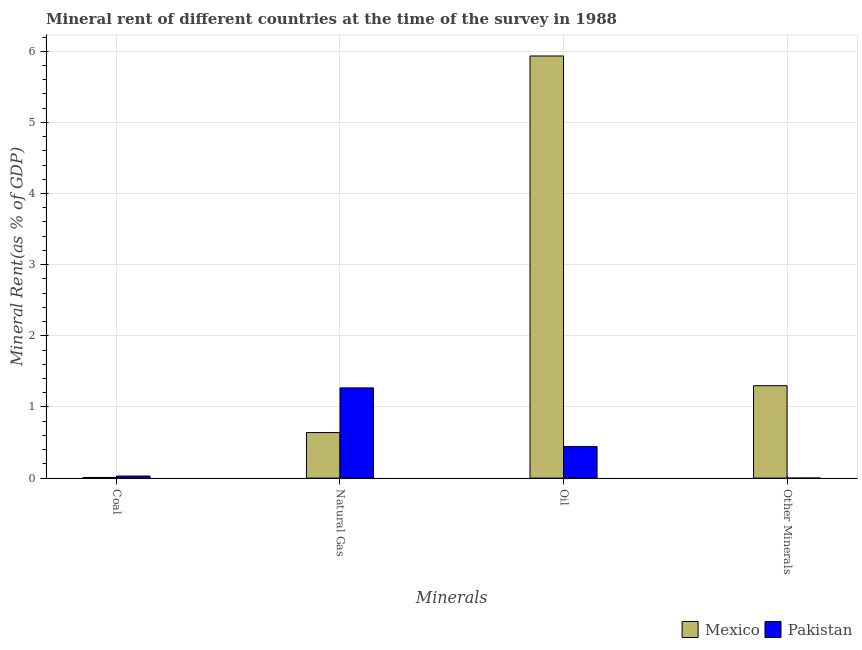What is the label of the 4th group of bars from the left?
Offer a very short reply. Other Minerals. What is the  rent of other minerals in Pakistan?
Offer a terse response. 0. Across all countries, what is the maximum natural gas rent?
Ensure brevity in your answer.  1.27. Across all countries, what is the minimum coal rent?
Your answer should be very brief. 0.01. In which country was the oil rent maximum?
Ensure brevity in your answer.  Mexico. In which country was the natural gas rent minimum?
Provide a short and direct response. Mexico. What is the total coal rent in the graph?
Keep it short and to the point. 0.04. What is the difference between the coal rent in Mexico and that in Pakistan?
Make the answer very short. -0.02. What is the difference between the  rent of other minerals in Pakistan and the natural gas rent in Mexico?
Offer a very short reply. -0.64. What is the average oil rent per country?
Keep it short and to the point. 3.19. What is the difference between the coal rent and oil rent in Pakistan?
Give a very brief answer. -0.41. In how many countries, is the oil rent greater than 2.8 %?
Keep it short and to the point. 1. What is the ratio of the oil rent in Mexico to that in Pakistan?
Give a very brief answer. 13.37. What is the difference between the highest and the second highest coal rent?
Offer a terse response. 0.02. What is the difference between the highest and the lowest natural gas rent?
Ensure brevity in your answer.  0.63. Is it the case that in every country, the sum of the coal rent and natural gas rent is greater than the oil rent?
Provide a succinct answer. No. How many bars are there?
Make the answer very short. 8. Are the values on the major ticks of Y-axis written in scientific E-notation?
Offer a terse response. No. Does the graph contain grids?
Offer a very short reply. Yes. What is the title of the graph?
Provide a succinct answer. Mineral rent of different countries at the time of the survey in 1988. Does "Monaco" appear as one of the legend labels in the graph?
Your response must be concise. No. What is the label or title of the X-axis?
Offer a very short reply. Minerals. What is the label or title of the Y-axis?
Make the answer very short. Mineral Rent(as % of GDP). What is the Mineral Rent(as % of GDP) in Mexico in Coal?
Ensure brevity in your answer.  0.01. What is the Mineral Rent(as % of GDP) of Pakistan in Coal?
Provide a short and direct response. 0.03. What is the Mineral Rent(as % of GDP) in Mexico in Natural Gas?
Give a very brief answer. 0.64. What is the Mineral Rent(as % of GDP) in Pakistan in Natural Gas?
Your response must be concise. 1.27. What is the Mineral Rent(as % of GDP) in Mexico in Oil?
Provide a succinct answer. 5.93. What is the Mineral Rent(as % of GDP) in Pakistan in Oil?
Make the answer very short. 0.44. What is the Mineral Rent(as % of GDP) in Mexico in Other Minerals?
Ensure brevity in your answer.  1.3. What is the Mineral Rent(as % of GDP) in Pakistan in Other Minerals?
Provide a succinct answer. 0. Across all Minerals, what is the maximum Mineral Rent(as % of GDP) of Mexico?
Ensure brevity in your answer.  5.93. Across all Minerals, what is the maximum Mineral Rent(as % of GDP) of Pakistan?
Offer a very short reply. 1.27. Across all Minerals, what is the minimum Mineral Rent(as % of GDP) of Mexico?
Your response must be concise. 0.01. Across all Minerals, what is the minimum Mineral Rent(as % of GDP) in Pakistan?
Your answer should be very brief. 0. What is the total Mineral Rent(as % of GDP) of Mexico in the graph?
Make the answer very short. 7.88. What is the total Mineral Rent(as % of GDP) of Pakistan in the graph?
Offer a very short reply. 1.74. What is the difference between the Mineral Rent(as % of GDP) of Mexico in Coal and that in Natural Gas?
Give a very brief answer. -0.63. What is the difference between the Mineral Rent(as % of GDP) in Pakistan in Coal and that in Natural Gas?
Keep it short and to the point. -1.24. What is the difference between the Mineral Rent(as % of GDP) of Mexico in Coal and that in Oil?
Your answer should be compact. -5.92. What is the difference between the Mineral Rent(as % of GDP) in Pakistan in Coal and that in Oil?
Give a very brief answer. -0.41. What is the difference between the Mineral Rent(as % of GDP) in Mexico in Coal and that in Other Minerals?
Provide a short and direct response. -1.29. What is the difference between the Mineral Rent(as % of GDP) in Pakistan in Coal and that in Other Minerals?
Provide a succinct answer. 0.03. What is the difference between the Mineral Rent(as % of GDP) of Mexico in Natural Gas and that in Oil?
Ensure brevity in your answer.  -5.29. What is the difference between the Mineral Rent(as % of GDP) in Pakistan in Natural Gas and that in Oil?
Ensure brevity in your answer.  0.82. What is the difference between the Mineral Rent(as % of GDP) of Mexico in Natural Gas and that in Other Minerals?
Offer a very short reply. -0.66. What is the difference between the Mineral Rent(as % of GDP) of Pakistan in Natural Gas and that in Other Minerals?
Your answer should be compact. 1.27. What is the difference between the Mineral Rent(as % of GDP) of Mexico in Oil and that in Other Minerals?
Ensure brevity in your answer.  4.63. What is the difference between the Mineral Rent(as % of GDP) of Pakistan in Oil and that in Other Minerals?
Your answer should be very brief. 0.44. What is the difference between the Mineral Rent(as % of GDP) in Mexico in Coal and the Mineral Rent(as % of GDP) in Pakistan in Natural Gas?
Offer a terse response. -1.26. What is the difference between the Mineral Rent(as % of GDP) of Mexico in Coal and the Mineral Rent(as % of GDP) of Pakistan in Oil?
Keep it short and to the point. -0.43. What is the difference between the Mineral Rent(as % of GDP) of Mexico in Coal and the Mineral Rent(as % of GDP) of Pakistan in Other Minerals?
Provide a short and direct response. 0.01. What is the difference between the Mineral Rent(as % of GDP) of Mexico in Natural Gas and the Mineral Rent(as % of GDP) of Pakistan in Oil?
Your answer should be compact. 0.2. What is the difference between the Mineral Rent(as % of GDP) of Mexico in Natural Gas and the Mineral Rent(as % of GDP) of Pakistan in Other Minerals?
Provide a succinct answer. 0.64. What is the difference between the Mineral Rent(as % of GDP) in Mexico in Oil and the Mineral Rent(as % of GDP) in Pakistan in Other Minerals?
Your answer should be very brief. 5.93. What is the average Mineral Rent(as % of GDP) in Mexico per Minerals?
Offer a very short reply. 1.97. What is the average Mineral Rent(as % of GDP) in Pakistan per Minerals?
Your answer should be compact. 0.44. What is the difference between the Mineral Rent(as % of GDP) in Mexico and Mineral Rent(as % of GDP) in Pakistan in Coal?
Your answer should be very brief. -0.02. What is the difference between the Mineral Rent(as % of GDP) in Mexico and Mineral Rent(as % of GDP) in Pakistan in Natural Gas?
Provide a short and direct response. -0.63. What is the difference between the Mineral Rent(as % of GDP) of Mexico and Mineral Rent(as % of GDP) of Pakistan in Oil?
Provide a succinct answer. 5.49. What is the difference between the Mineral Rent(as % of GDP) in Mexico and Mineral Rent(as % of GDP) in Pakistan in Other Minerals?
Your answer should be compact. 1.3. What is the ratio of the Mineral Rent(as % of GDP) in Mexico in Coal to that in Natural Gas?
Ensure brevity in your answer.  0.01. What is the ratio of the Mineral Rent(as % of GDP) of Pakistan in Coal to that in Natural Gas?
Your answer should be compact. 0.02. What is the ratio of the Mineral Rent(as % of GDP) in Mexico in Coal to that in Oil?
Offer a very short reply. 0. What is the ratio of the Mineral Rent(as % of GDP) in Pakistan in Coal to that in Oil?
Make the answer very short. 0.07. What is the ratio of the Mineral Rent(as % of GDP) of Mexico in Coal to that in Other Minerals?
Provide a succinct answer. 0.01. What is the ratio of the Mineral Rent(as % of GDP) in Pakistan in Coal to that in Other Minerals?
Keep it short and to the point. 180.05. What is the ratio of the Mineral Rent(as % of GDP) of Mexico in Natural Gas to that in Oil?
Your answer should be compact. 0.11. What is the ratio of the Mineral Rent(as % of GDP) of Pakistan in Natural Gas to that in Oil?
Offer a very short reply. 2.86. What is the ratio of the Mineral Rent(as % of GDP) in Mexico in Natural Gas to that in Other Minerals?
Make the answer very short. 0.49. What is the ratio of the Mineral Rent(as % of GDP) in Pakistan in Natural Gas to that in Other Minerals?
Make the answer very short. 7801.96. What is the ratio of the Mineral Rent(as % of GDP) of Mexico in Oil to that in Other Minerals?
Offer a terse response. 4.57. What is the ratio of the Mineral Rent(as % of GDP) of Pakistan in Oil to that in Other Minerals?
Your answer should be compact. 2730.04. What is the difference between the highest and the second highest Mineral Rent(as % of GDP) in Mexico?
Your answer should be compact. 4.63. What is the difference between the highest and the second highest Mineral Rent(as % of GDP) in Pakistan?
Your answer should be compact. 0.82. What is the difference between the highest and the lowest Mineral Rent(as % of GDP) in Mexico?
Your answer should be compact. 5.92. What is the difference between the highest and the lowest Mineral Rent(as % of GDP) in Pakistan?
Offer a terse response. 1.27. 